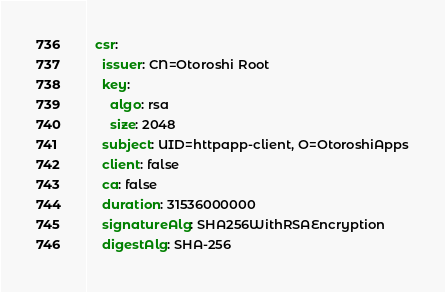Convert code to text. <code><loc_0><loc_0><loc_500><loc_500><_YAML_>  csr:
    issuer: CN=Otoroshi Root
    key:
      algo: rsa
      size: 2048
    subject: UID=httpapp-client, O=OtoroshiApps
    client: false
    ca: false
    duration: 31536000000
    signatureAlg: SHA256WithRSAEncryption
    digestAlg: SHA-256</code> 